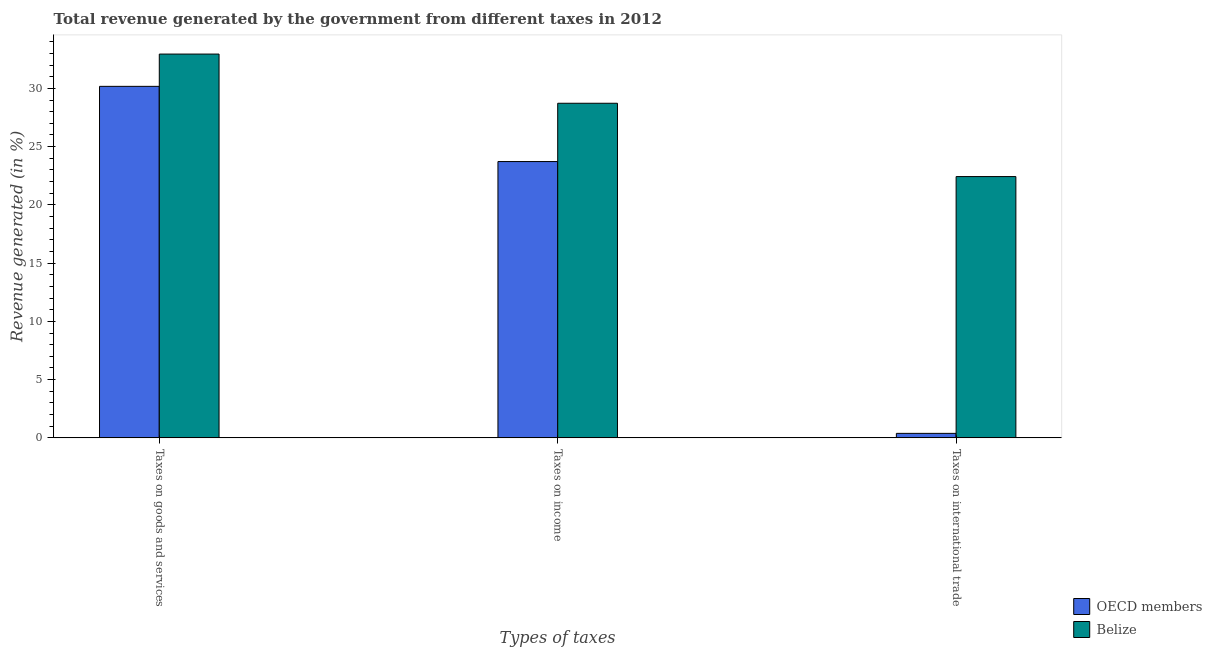Are the number of bars per tick equal to the number of legend labels?
Give a very brief answer. Yes. Are the number of bars on each tick of the X-axis equal?
Offer a terse response. Yes. How many bars are there on the 3rd tick from the left?
Make the answer very short. 2. How many bars are there on the 1st tick from the right?
Provide a succinct answer. 2. What is the label of the 2nd group of bars from the left?
Offer a very short reply. Taxes on income. What is the percentage of revenue generated by tax on international trade in OECD members?
Provide a short and direct response. 0.39. Across all countries, what is the maximum percentage of revenue generated by tax on international trade?
Your answer should be very brief. 22.43. Across all countries, what is the minimum percentage of revenue generated by taxes on income?
Keep it short and to the point. 23.72. In which country was the percentage of revenue generated by taxes on goods and services maximum?
Give a very brief answer. Belize. In which country was the percentage of revenue generated by taxes on goods and services minimum?
Offer a very short reply. OECD members. What is the total percentage of revenue generated by taxes on goods and services in the graph?
Ensure brevity in your answer.  63.12. What is the difference between the percentage of revenue generated by taxes on goods and services in OECD members and that in Belize?
Your answer should be very brief. -2.77. What is the difference between the percentage of revenue generated by taxes on goods and services in OECD members and the percentage of revenue generated by tax on international trade in Belize?
Give a very brief answer. 7.74. What is the average percentage of revenue generated by tax on international trade per country?
Provide a short and direct response. 11.41. What is the difference between the percentage of revenue generated by taxes on income and percentage of revenue generated by tax on international trade in Belize?
Your answer should be very brief. 6.29. What is the ratio of the percentage of revenue generated by tax on international trade in OECD members to that in Belize?
Offer a terse response. 0.02. What is the difference between the highest and the second highest percentage of revenue generated by taxes on income?
Make the answer very short. 5. What is the difference between the highest and the lowest percentage of revenue generated by taxes on income?
Your answer should be very brief. 5. Is the sum of the percentage of revenue generated by taxes on income in Belize and OECD members greater than the maximum percentage of revenue generated by tax on international trade across all countries?
Provide a short and direct response. Yes. What does the 1st bar from the right in Taxes on goods and services represents?
Your answer should be compact. Belize. How many bars are there?
Your answer should be compact. 6. Are all the bars in the graph horizontal?
Your answer should be very brief. No. How many countries are there in the graph?
Your answer should be very brief. 2. What is the difference between two consecutive major ticks on the Y-axis?
Offer a very short reply. 5. Are the values on the major ticks of Y-axis written in scientific E-notation?
Make the answer very short. No. Does the graph contain grids?
Your response must be concise. No. Where does the legend appear in the graph?
Provide a succinct answer. Bottom right. What is the title of the graph?
Provide a short and direct response. Total revenue generated by the government from different taxes in 2012. What is the label or title of the X-axis?
Provide a succinct answer. Types of taxes. What is the label or title of the Y-axis?
Make the answer very short. Revenue generated (in %). What is the Revenue generated (in %) in OECD members in Taxes on goods and services?
Your response must be concise. 30.17. What is the Revenue generated (in %) of Belize in Taxes on goods and services?
Offer a very short reply. 32.95. What is the Revenue generated (in %) of OECD members in Taxes on income?
Provide a succinct answer. 23.72. What is the Revenue generated (in %) of Belize in Taxes on income?
Make the answer very short. 28.72. What is the Revenue generated (in %) in OECD members in Taxes on international trade?
Keep it short and to the point. 0.39. What is the Revenue generated (in %) of Belize in Taxes on international trade?
Make the answer very short. 22.43. Across all Types of taxes, what is the maximum Revenue generated (in %) in OECD members?
Provide a succinct answer. 30.17. Across all Types of taxes, what is the maximum Revenue generated (in %) of Belize?
Provide a short and direct response. 32.95. Across all Types of taxes, what is the minimum Revenue generated (in %) of OECD members?
Your answer should be compact. 0.39. Across all Types of taxes, what is the minimum Revenue generated (in %) in Belize?
Offer a terse response. 22.43. What is the total Revenue generated (in %) of OECD members in the graph?
Provide a short and direct response. 54.28. What is the total Revenue generated (in %) in Belize in the graph?
Your response must be concise. 84.1. What is the difference between the Revenue generated (in %) in OECD members in Taxes on goods and services and that in Taxes on income?
Your response must be concise. 6.46. What is the difference between the Revenue generated (in %) of Belize in Taxes on goods and services and that in Taxes on income?
Give a very brief answer. 4.22. What is the difference between the Revenue generated (in %) in OECD members in Taxes on goods and services and that in Taxes on international trade?
Your answer should be compact. 29.79. What is the difference between the Revenue generated (in %) of Belize in Taxes on goods and services and that in Taxes on international trade?
Keep it short and to the point. 10.52. What is the difference between the Revenue generated (in %) of OECD members in Taxes on income and that in Taxes on international trade?
Keep it short and to the point. 23.33. What is the difference between the Revenue generated (in %) in Belize in Taxes on income and that in Taxes on international trade?
Your response must be concise. 6.29. What is the difference between the Revenue generated (in %) in OECD members in Taxes on goods and services and the Revenue generated (in %) in Belize in Taxes on income?
Offer a very short reply. 1.45. What is the difference between the Revenue generated (in %) in OECD members in Taxes on goods and services and the Revenue generated (in %) in Belize in Taxes on international trade?
Your response must be concise. 7.74. What is the difference between the Revenue generated (in %) of OECD members in Taxes on income and the Revenue generated (in %) of Belize in Taxes on international trade?
Make the answer very short. 1.29. What is the average Revenue generated (in %) of OECD members per Types of taxes?
Keep it short and to the point. 18.09. What is the average Revenue generated (in %) in Belize per Types of taxes?
Ensure brevity in your answer.  28.03. What is the difference between the Revenue generated (in %) of OECD members and Revenue generated (in %) of Belize in Taxes on goods and services?
Offer a terse response. -2.77. What is the difference between the Revenue generated (in %) of OECD members and Revenue generated (in %) of Belize in Taxes on income?
Make the answer very short. -5. What is the difference between the Revenue generated (in %) in OECD members and Revenue generated (in %) in Belize in Taxes on international trade?
Give a very brief answer. -22.04. What is the ratio of the Revenue generated (in %) in OECD members in Taxes on goods and services to that in Taxes on income?
Your response must be concise. 1.27. What is the ratio of the Revenue generated (in %) of Belize in Taxes on goods and services to that in Taxes on income?
Offer a very short reply. 1.15. What is the ratio of the Revenue generated (in %) in OECD members in Taxes on goods and services to that in Taxes on international trade?
Give a very brief answer. 78.2. What is the ratio of the Revenue generated (in %) in Belize in Taxes on goods and services to that in Taxes on international trade?
Provide a short and direct response. 1.47. What is the ratio of the Revenue generated (in %) of OECD members in Taxes on income to that in Taxes on international trade?
Your answer should be very brief. 61.47. What is the ratio of the Revenue generated (in %) of Belize in Taxes on income to that in Taxes on international trade?
Make the answer very short. 1.28. What is the difference between the highest and the second highest Revenue generated (in %) in OECD members?
Offer a very short reply. 6.46. What is the difference between the highest and the second highest Revenue generated (in %) in Belize?
Your answer should be compact. 4.22. What is the difference between the highest and the lowest Revenue generated (in %) of OECD members?
Provide a short and direct response. 29.79. What is the difference between the highest and the lowest Revenue generated (in %) in Belize?
Give a very brief answer. 10.52. 